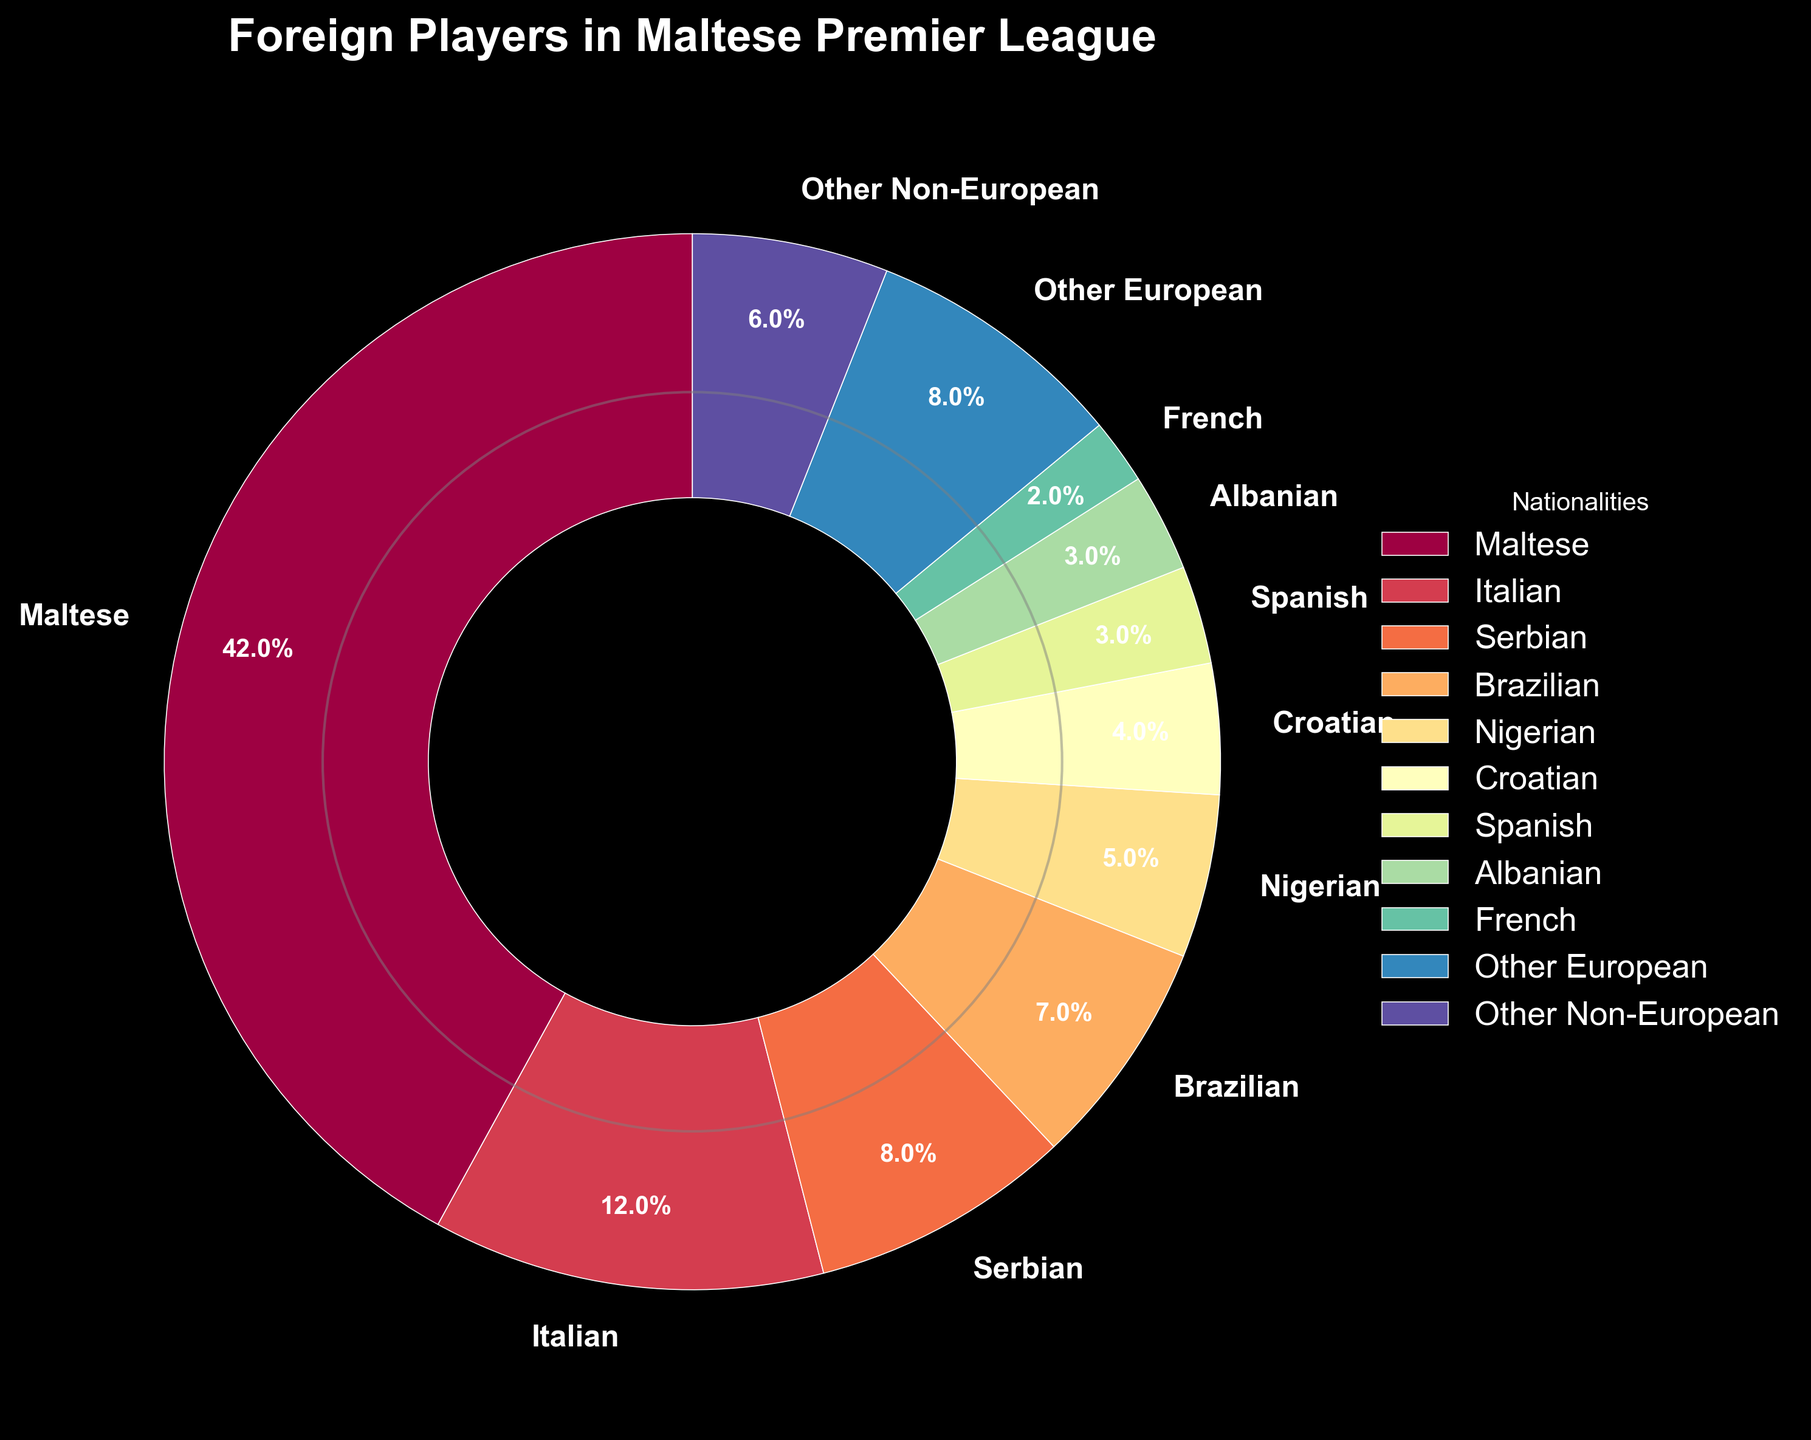What's the percentage of Maltese players compared to Italian players? First, look at the percentage for Maltese players, which is 42%. Then, look at the percentage for Italian players, which is 12%. Compare these values: 42% (Maltese) is greater than 12% (Italian).
Answer: Maltese players have a higher percentage Which nationality has the third-highest representation of foreign players? Look at the percentages and sort them from highest to lowest. The highest is Maltese (42%), Italian (12%), and then Serbian (8%). Therefore, Serbian is the third-highest.
Answer: Serbian What is the combined percentage of Brazilian, Nigerian, and Croatian players? Add the percentage values for Brazilian (7%), Nigerian (5%), and Croatian (4%). The combined percentage is 7 + 5 + 4 = 16%.
Answer: 16% Which group is larger: "Other European" players or "Other Non-European" players? Look at the percentages for "Other European" (8%) and "Other Non-European" (6%). Compare these values: 8% (Other European) is larger than 6% (Other Non-European).
Answer: Other European What is the percentage difference between the highest and lowest foreign player nationalities? The highest percentage for a foreign player nationality is Italian (12%) and the lowest is French (2%). Subtract these values: 12 - 2 = 10%.
Answer: 10% How does the percentage of Albanian players compare to Spanish players? The percentage for Albanian players is 3%, and the percentage for Spanish players is also 3%. Since both have the same percentage, Albanian and Spanish players are equal in representation.
Answer: They are equal What is the average percentage of the top three foreign nationalities? The top three foreign nationalities by percentage are Italian (12%), Serbian (8%), and Brazilian (7%). Calculate the average: (12 + 8 + 7) / 3 = 27 / 3 = 9%.
Answer: 9% What is the total percentage of all foreign players combined? Add the percentages for all foreign players: 12 + 8 + 7 + 5 + 4 + 3 + 3 + 2 + 8 + 6 = 58%. The total percentage for all foreign players is 100% - 42% (Maltese) = 58%.
Answer: 58% Which nationality has a higher percentage than French but lower than Nigerian? Look at the percentages for French (2%) and Nigerian (5%). The nationalities that fall between these values are Croatian (4%), which is the only one between 2% and 5%.
Answer: Croatian What is the ratio of Nigerian players to the overall foreign players (excluding Maltese)? The percentage of Nigerian players is 5%. The total percentage of foreign players is 100% - 42% (Maltese) = 58%. The ratio is 5 / 58. Simplify this ratio by dividing both numbers by their greatest common divisor, 1, to get 5:58.
Answer: 5:58 